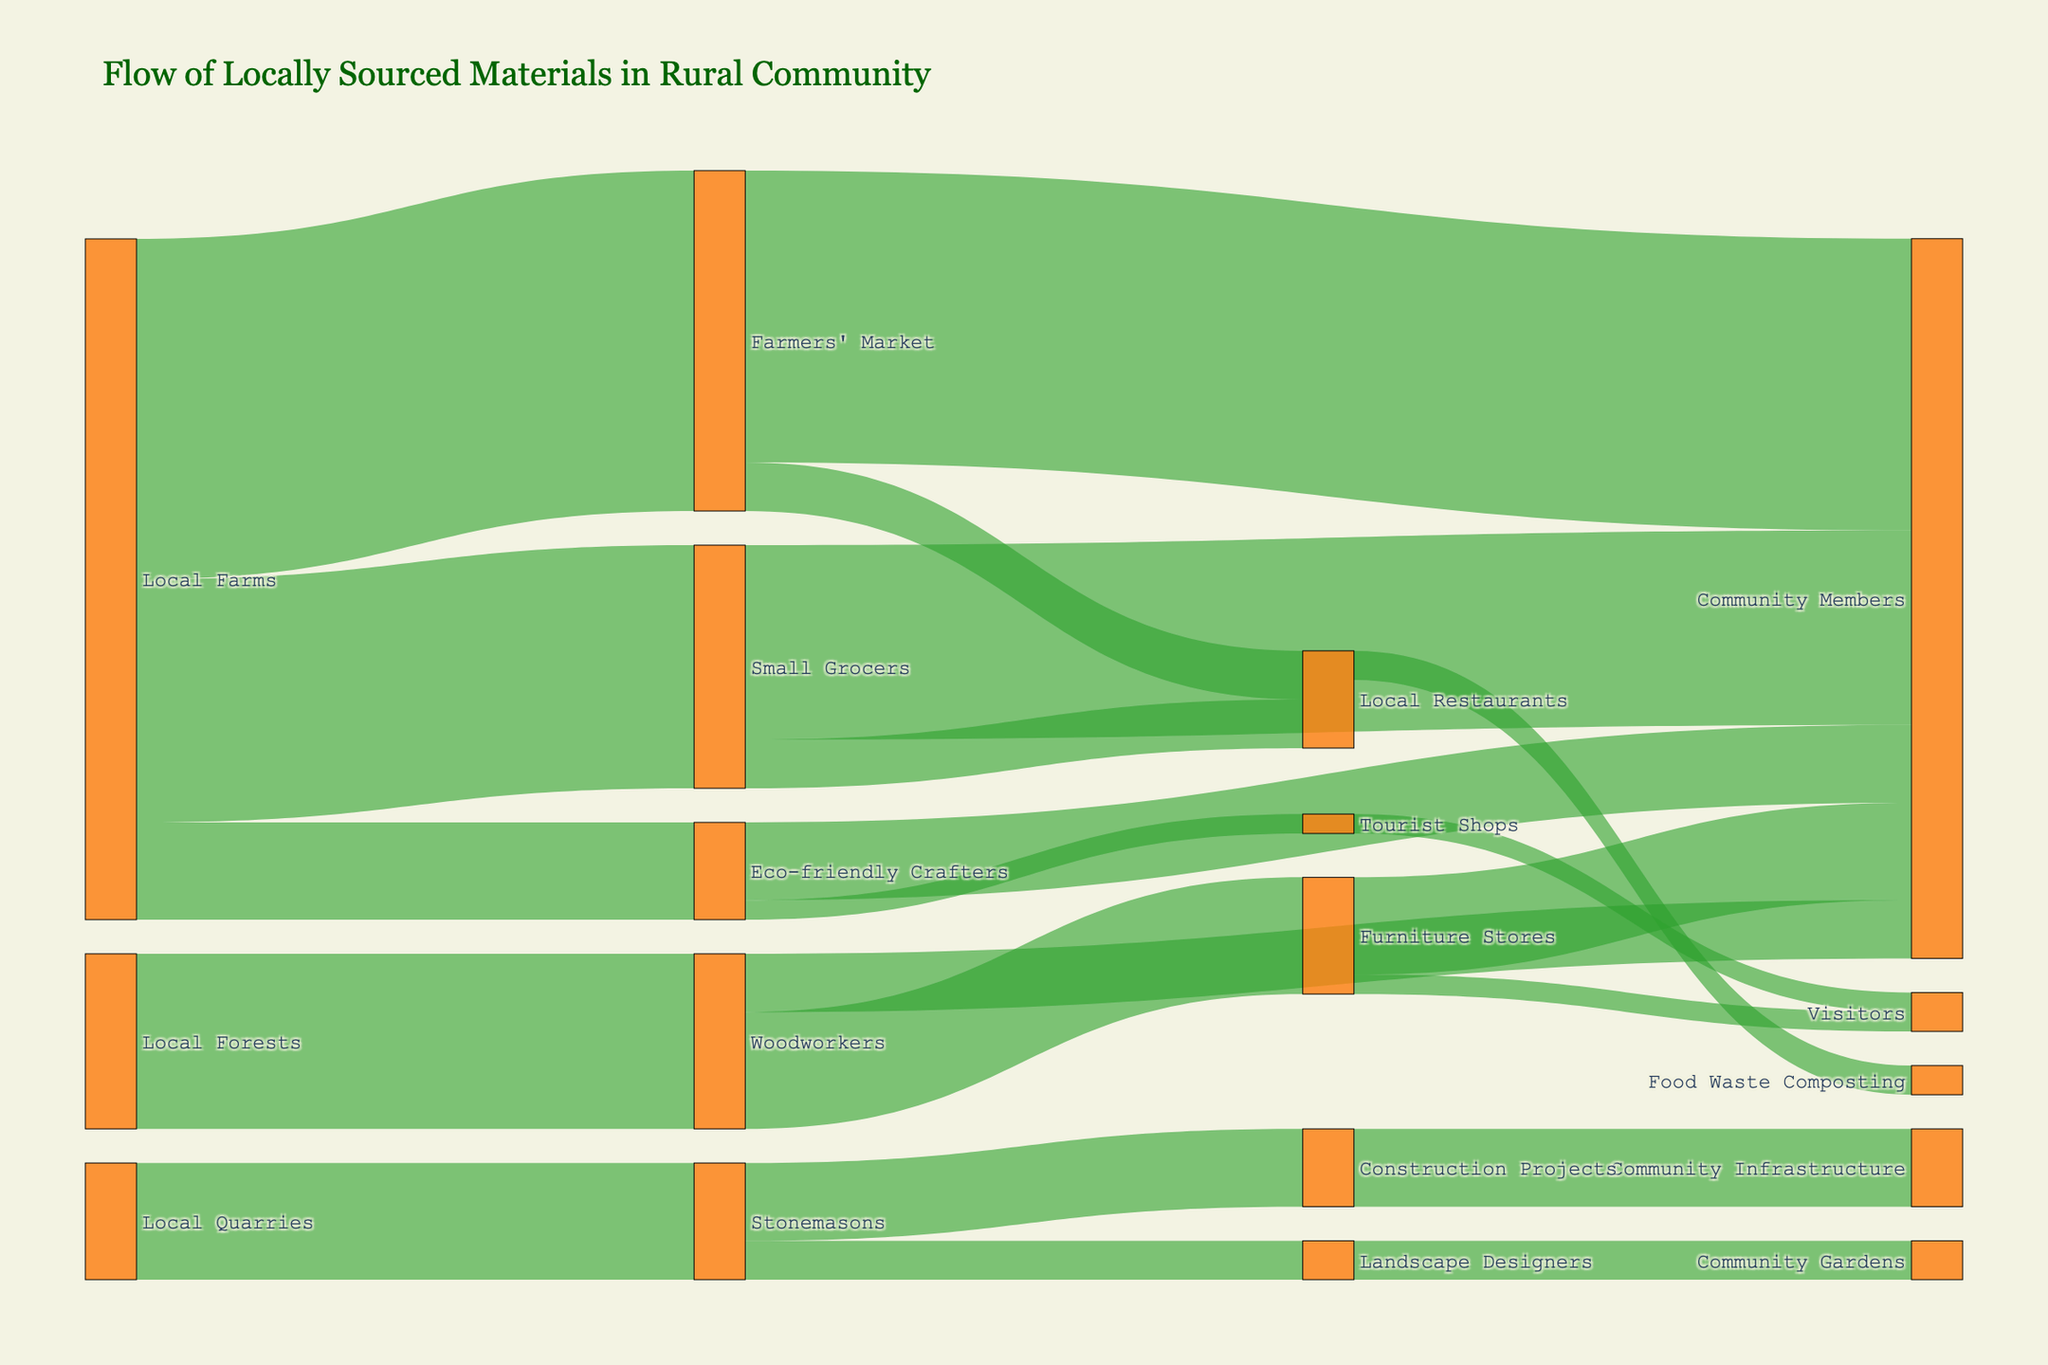What is the title of the Sankey diagram? Look at the top of the diagram, where the main heading is located.
Answer: Flow of Locally Sourced Materials in Rural Community Which node transfers the highest amount of material? Check the connections from each source node and sum the values. The Local Farms node transfers 250 + 350 + 100 = 700 units.
Answer: Local Farms How many units of material flow from Local Grocers to Community Members? Trace the connection labeled from Small Grocers to Community Members and read the value attached to it.
Answer: 200 Which target receives the smallest amount of material? Compare the smallest values attached to all target nodes: (Tourist Shops: 20, Visitors: 20).
Answer: Tourist Shops and Visitors What is the total amount of material locally sourced from Local Forests and Local Quarries combined? Sum the values of all transfers originating from Local Forests (180) and Local Quarries (120). 180 + 120 = 300.
Answer: 300 How many total units of flow go to Local Restaurants? Sum the values of flows going to Local Restaurants from Small Grocers and Farmers' Market. 50 + 50 = 100.
Answer: 100 Which sub-community benefits the most from Eco-friendly Crafters? Compare the flows going from Eco-friendly Crafters, specifically to Community Members (80) and Tourist Shops (20) and identify the higher value.
Answer: Community Members What percentage of materials sourced from Local Farms goes to Farmers' Market? Calculate the portion: (350 / 700) * 100. Hence, 50% of materials sourced from Local Farms go to Farmers' Market.
Answer: 50% Which two nodes act as both sources and targets? Look for nodes involved in both incoming and outgoing flows. Local Restaurants and Eco-friendly Crafters appear in both roles.
Answer: Local Restaurants and Eco-friendly Crafters What is the total amount of material flowing to Community Members? Sum all flows ending at Community Members from various sources: 200 (Small Grocers) + 300 (Farmers' Market) + 80 (Eco-friendly Crafters) + 60 (Woodworkers) + 100 (Furniture Stores). The total is 740.
Answer: 740 